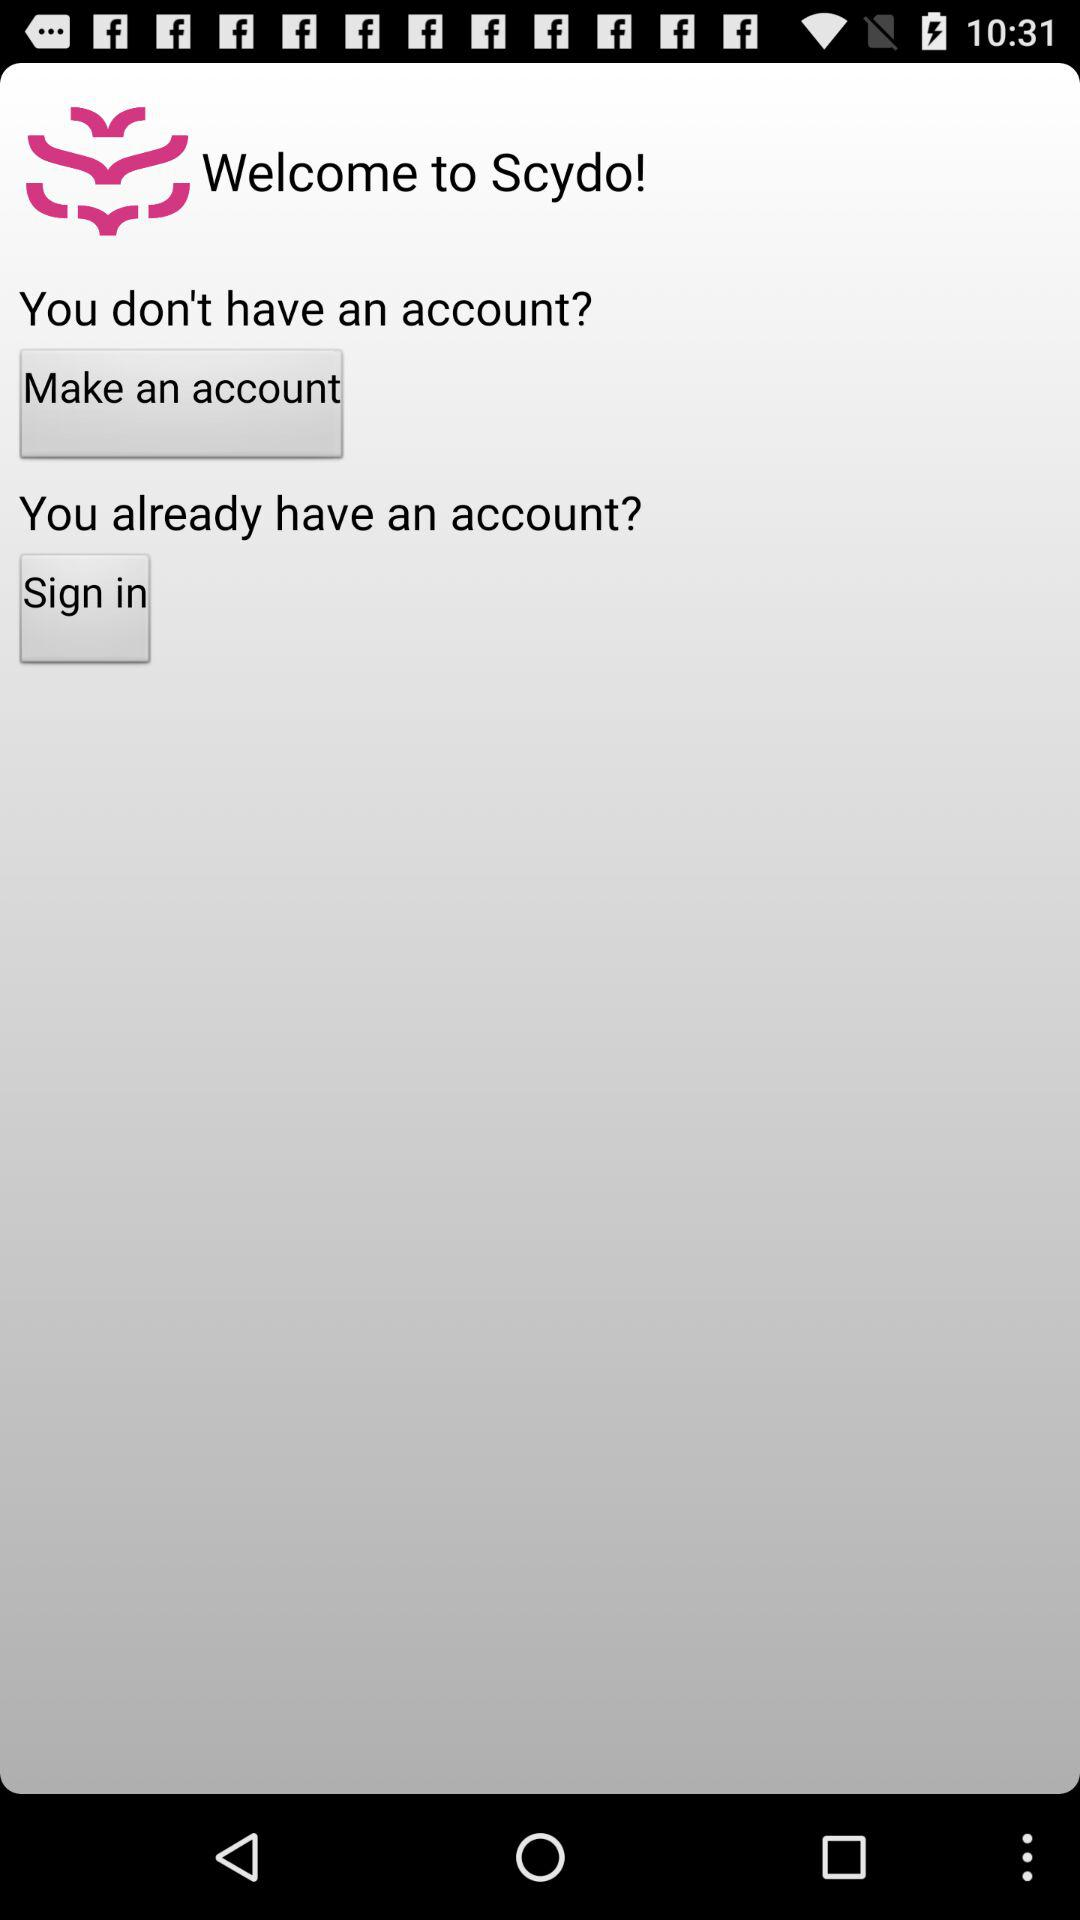What is the application name? The application name is "Welcome to Scydo!". 